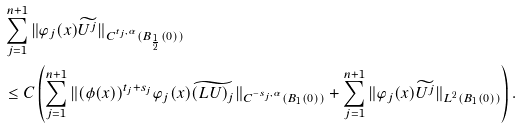Convert formula to latex. <formula><loc_0><loc_0><loc_500><loc_500>& \sum _ { j = 1 } ^ { n + 1 } \| \varphi _ { j } ( x ) \widetilde { U ^ { j } } \| _ { C ^ { t _ { j } , \alpha } ( B _ { \frac { 1 } { 2 } } ( 0 ) ) } \\ & \leq C \left ( \sum _ { j = 1 } ^ { n + 1 } \| ( \phi ( x ) ) ^ { t _ { j } + s _ { j } } \varphi _ { j } ( x ) \widetilde { ( L U ) _ { j } } \| _ { C ^ { - s _ { j } , \alpha } ( B _ { 1 } ( 0 ) ) } + \sum _ { j = 1 } ^ { n + 1 } \| \varphi _ { j } ( x ) \widetilde { U ^ { j } } \| _ { L ^ { 2 } ( B _ { 1 } ( 0 ) ) } \right ) .</formula> 